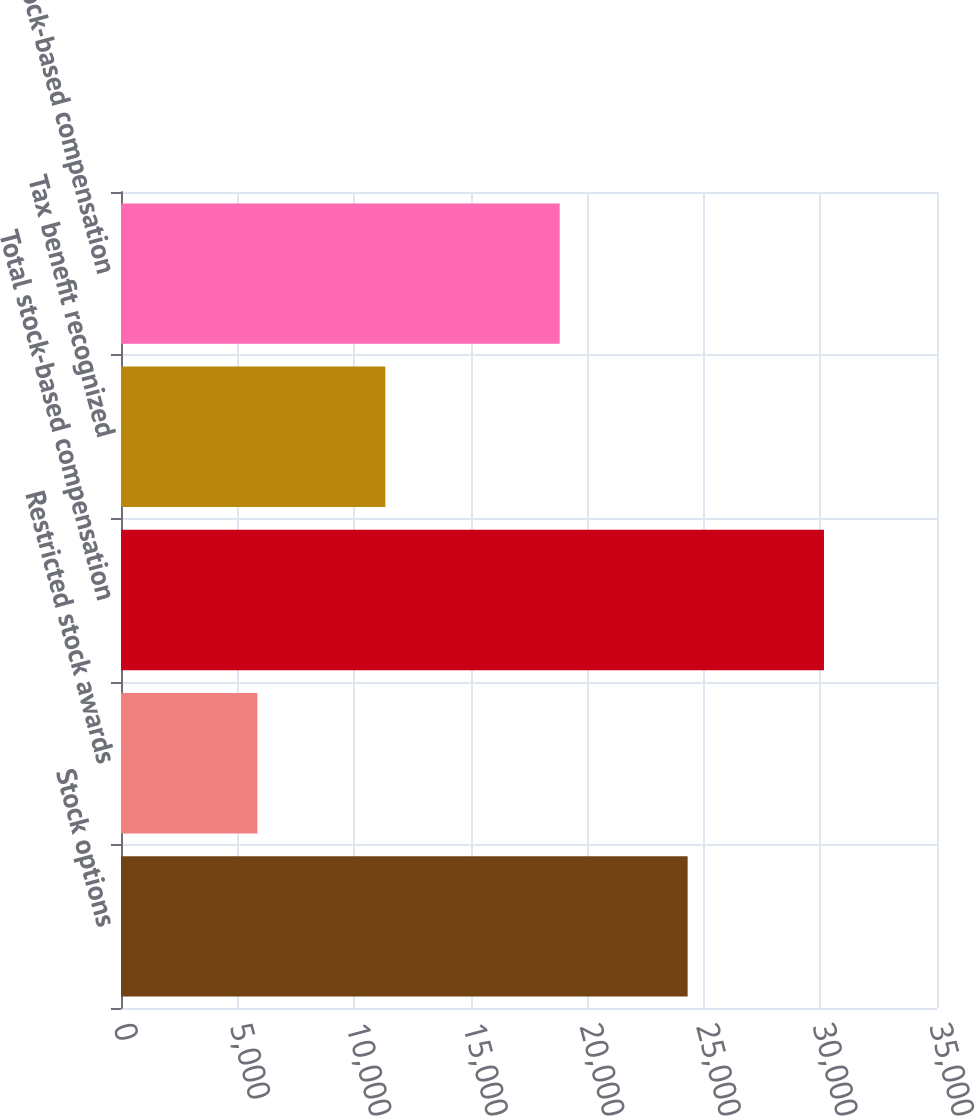<chart> <loc_0><loc_0><loc_500><loc_500><bar_chart><fcel>Stock options<fcel>Restricted stock awards<fcel>Total stock-based compensation<fcel>Tax benefit recognized<fcel>Stock-based compensation<nl><fcel>24304<fcel>5849<fcel>30153<fcel>11337<fcel>18816<nl></chart> 